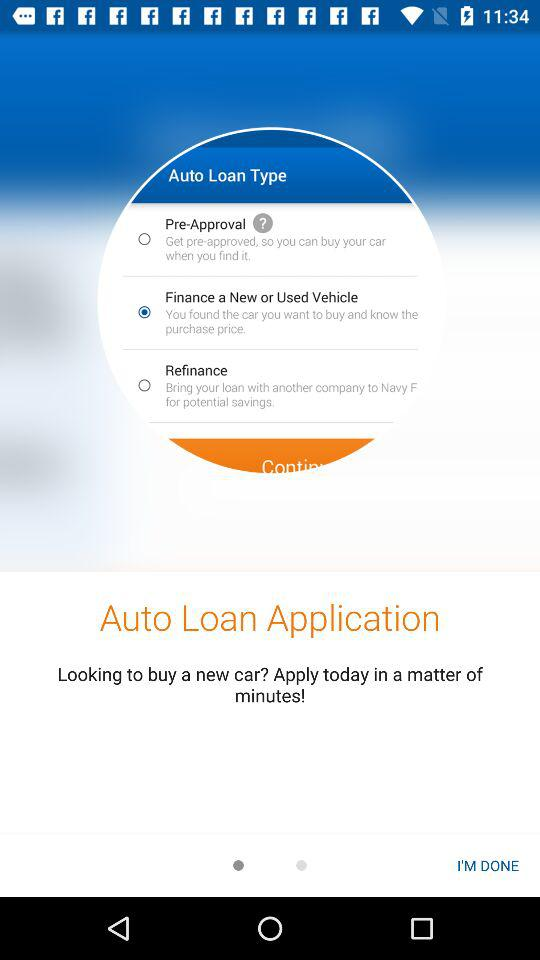Which type of auto loan is selected? The selected type is "Finance a New or Used Vehicle". 